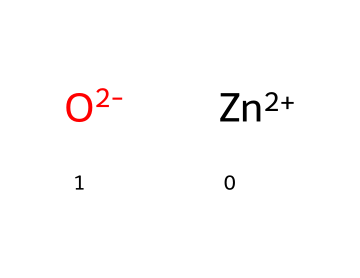What is the name of this chemical? The chemical composition shown represents zinc oxide, where "Zn" is the symbol for zinc, and "O" is for oxygen. Together they form zinc oxide.
Answer: zinc oxide How many atoms are in one molecule of zinc oxide? The chemical structure includes one zinc atom and one oxygen atom, making a total of two atoms in one molecule of zinc oxide.
Answer: 2 What type of bonding is present in zinc oxide? The structure indicates an ionic bond between zinc (Zn) and oxide (O), as zinc has a +2 charge and oxide has a -2 charge, creating an ionic compound.
Answer: ionic bond Is zinc oxide a crystalline or amorphous solid? Zinc oxide typically crystallizes in a hexagonal or cubic structure, making it a crystalline solid.
Answer: crystalline What is the primary application of zinc oxide in cosmetics? Zinc oxide is primarily used in mineral sunscreens to provide UV protection by reflecting and scattering UV rays.
Answer: sun protection How does zinc oxide function as a skin protectant? Zinc oxide forms a physical barrier on the skin that protects against environmental factors such as UV radiation and irritation.
Answer: barrier What are the properties of zinc oxide that make it beneficial for sensitive skin? Zinc oxide is known for its soothing properties, anti-inflammatory effects, and low allergenic potential, making it suitable for sensitive skin.
Answer: soothing properties 